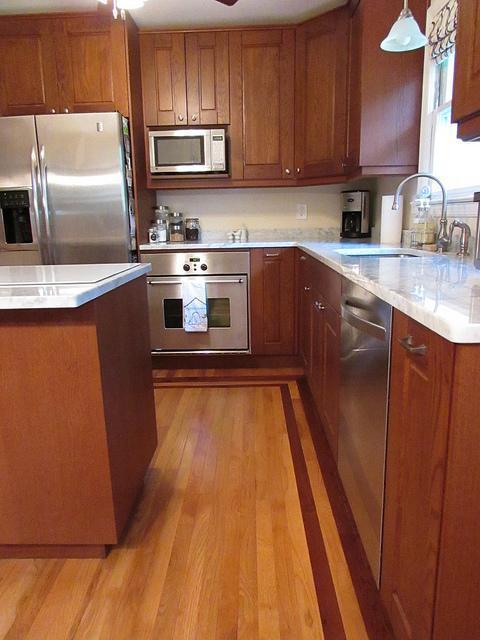How many people are not sitting?
Give a very brief answer. 0. 